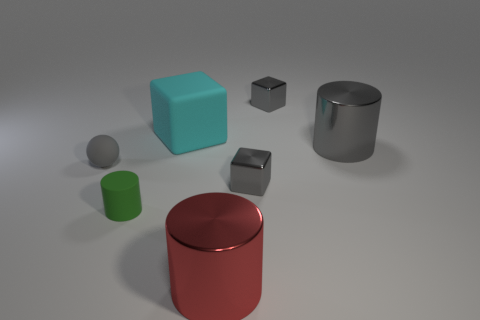Are the tiny sphere and the small block behind the gray sphere made of the same material?
Offer a very short reply. No. There is a large cube; are there any tiny gray metallic blocks in front of it?
Make the answer very short. Yes. What number of objects are tiny blue blocks or cubes left of the big red shiny thing?
Give a very brief answer. 1. What is the color of the big metal cylinder behind the small matte ball behind the green matte object?
Your response must be concise. Gray. What number of other things are there of the same material as the gray ball
Ensure brevity in your answer.  2. How many metallic objects are balls or big cylinders?
Offer a terse response. 2. What color is the small object that is the same shape as the big red shiny thing?
Provide a short and direct response. Green. What number of objects are either large yellow rubber cylinders or tiny gray spheres?
Your answer should be compact. 1. What is the shape of the green thing that is the same material as the cyan cube?
Offer a terse response. Cylinder. How many big objects are either brown rubber things or red things?
Provide a short and direct response. 1. 